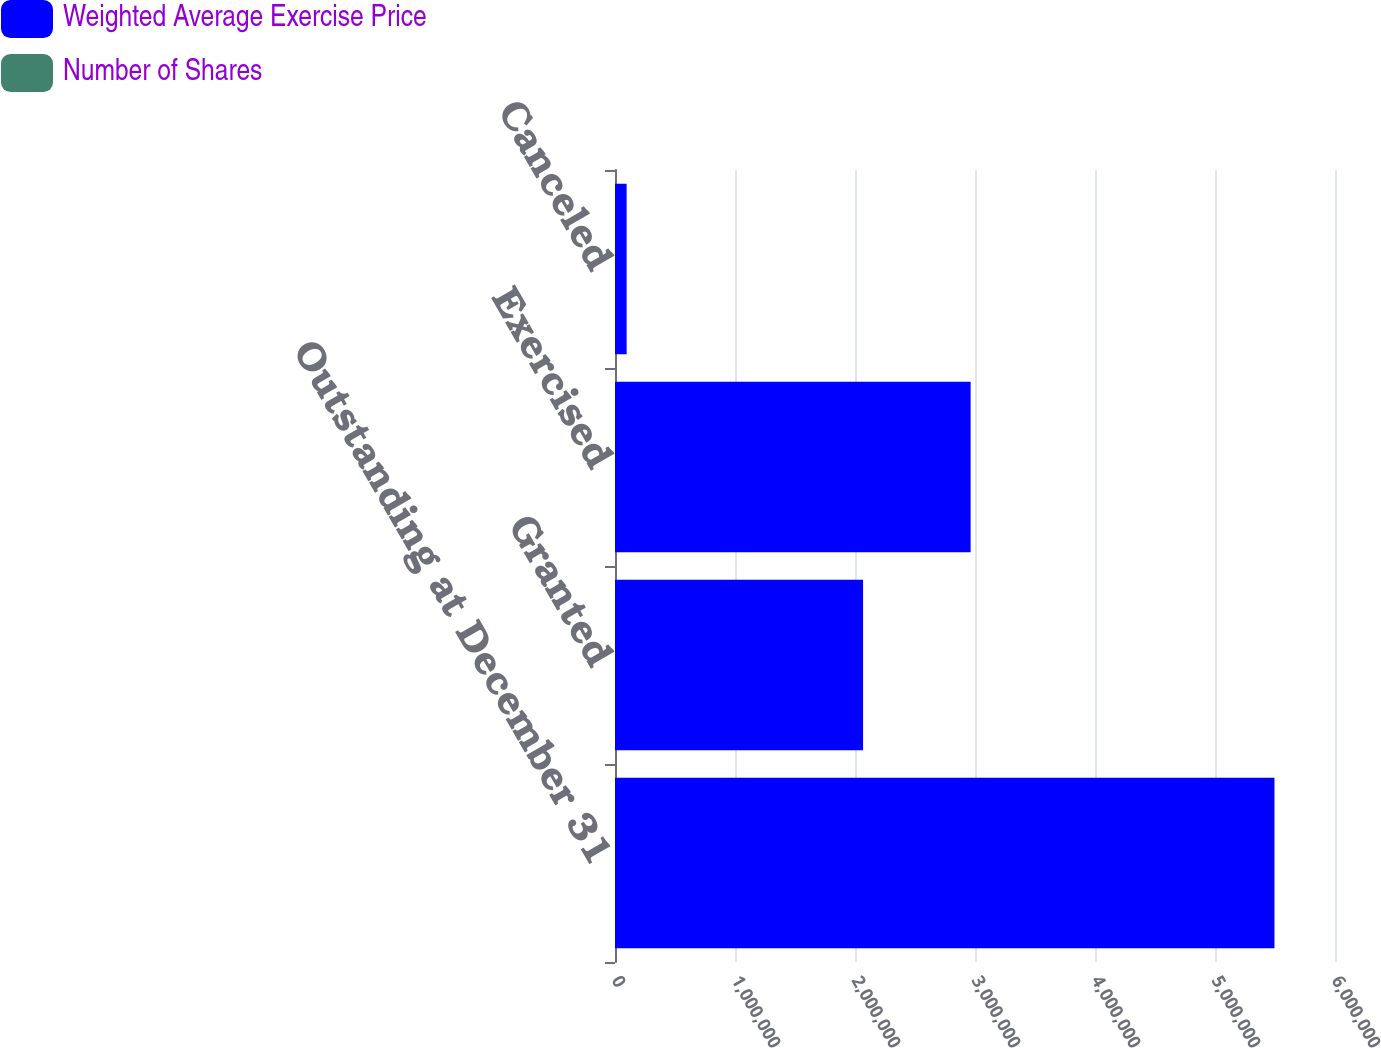<chart> <loc_0><loc_0><loc_500><loc_500><stacked_bar_chart><ecel><fcel>Outstanding at December 31<fcel>Granted<fcel>Exercised<fcel>Canceled<nl><fcel>Weighted Average Exercise Price<fcel>5.4955e+06<fcel>2.0673e+06<fcel>2.96355e+06<fcel>96886<nl><fcel>Number of Shares<fcel>49.43<fcel>33.28<fcel>17.17<fcel>30.78<nl></chart> 